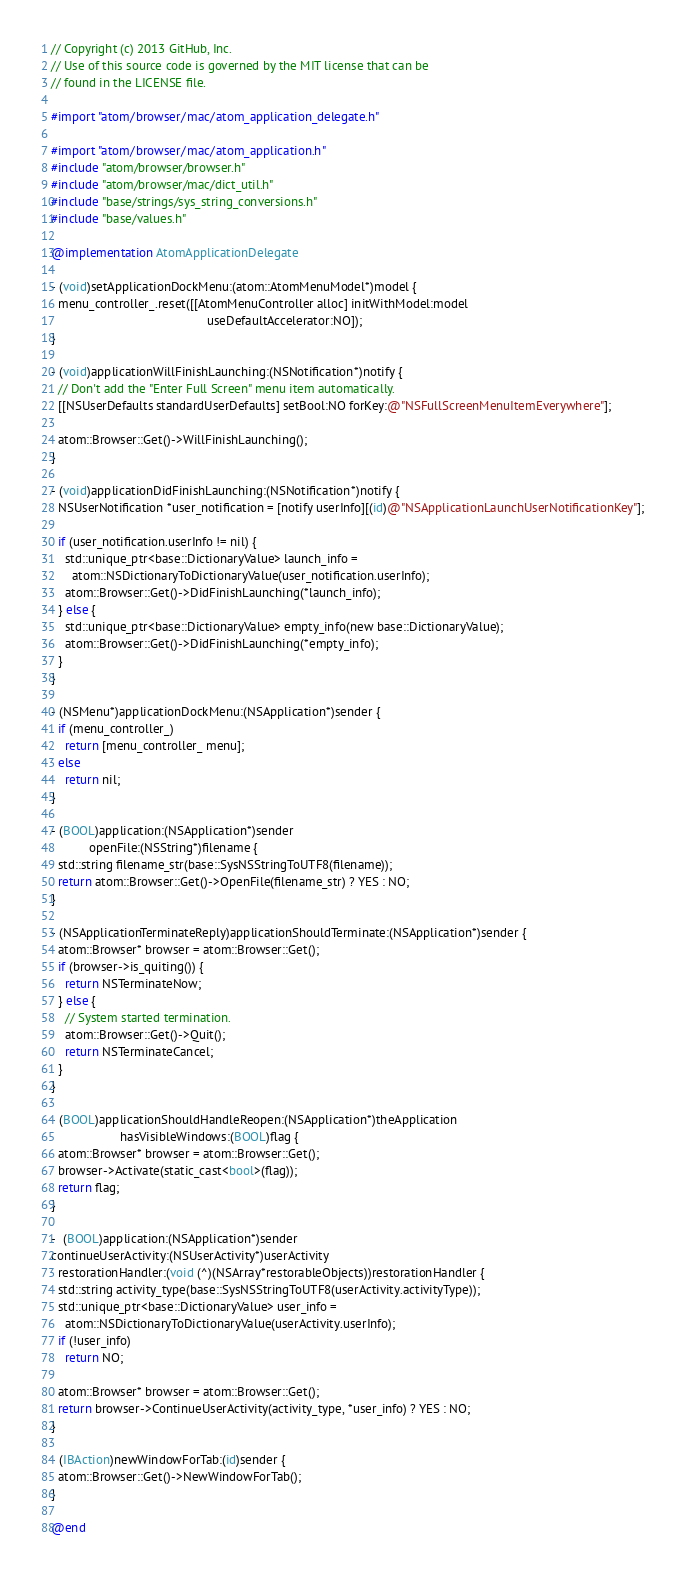<code> <loc_0><loc_0><loc_500><loc_500><_ObjectiveC_>// Copyright (c) 2013 GitHub, Inc.
// Use of this source code is governed by the MIT license that can be
// found in the LICENSE file.

#import "atom/browser/mac/atom_application_delegate.h"

#import "atom/browser/mac/atom_application.h"
#include "atom/browser/browser.h"
#include "atom/browser/mac/dict_util.h"
#include "base/strings/sys_string_conversions.h"
#include "base/values.h"

@implementation AtomApplicationDelegate

- (void)setApplicationDockMenu:(atom::AtomMenuModel*)model {
  menu_controller_.reset([[AtomMenuController alloc] initWithModel:model
                                             useDefaultAccelerator:NO]);
}

- (void)applicationWillFinishLaunching:(NSNotification*)notify {
  // Don't add the "Enter Full Screen" menu item automatically.
  [[NSUserDefaults standardUserDefaults] setBool:NO forKey:@"NSFullScreenMenuItemEverywhere"];

  atom::Browser::Get()->WillFinishLaunching();
}

- (void)applicationDidFinishLaunching:(NSNotification*)notify {
  NSUserNotification *user_notification = [notify userInfo][(id)@"NSApplicationLaunchUserNotificationKey"];

  if (user_notification.userInfo != nil) {
    std::unique_ptr<base::DictionaryValue> launch_info =
      atom::NSDictionaryToDictionaryValue(user_notification.userInfo);
    atom::Browser::Get()->DidFinishLaunching(*launch_info);
  } else {
    std::unique_ptr<base::DictionaryValue> empty_info(new base::DictionaryValue);
    atom::Browser::Get()->DidFinishLaunching(*empty_info);
  }
}

- (NSMenu*)applicationDockMenu:(NSApplication*)sender {
  if (menu_controller_)
    return [menu_controller_ menu];
  else
    return nil;
}

- (BOOL)application:(NSApplication*)sender
           openFile:(NSString*)filename {
  std::string filename_str(base::SysNSStringToUTF8(filename));
  return atom::Browser::Get()->OpenFile(filename_str) ? YES : NO;
}

- (NSApplicationTerminateReply)applicationShouldTerminate:(NSApplication*)sender {
  atom::Browser* browser = atom::Browser::Get();
  if (browser->is_quiting()) {
    return NSTerminateNow;
  } else {
    // System started termination.
    atom::Browser::Get()->Quit();
    return NSTerminateCancel;
  }
}

- (BOOL)applicationShouldHandleReopen:(NSApplication*)theApplication
                    hasVisibleWindows:(BOOL)flag {
  atom::Browser* browser = atom::Browser::Get();
  browser->Activate(static_cast<bool>(flag));
  return flag;
}

-  (BOOL)application:(NSApplication*)sender
continueUserActivity:(NSUserActivity*)userActivity
  restorationHandler:(void (^)(NSArray*restorableObjects))restorationHandler {
  std::string activity_type(base::SysNSStringToUTF8(userActivity.activityType));
  std::unique_ptr<base::DictionaryValue> user_info =
    atom::NSDictionaryToDictionaryValue(userActivity.userInfo);
  if (!user_info)
    return NO;

  atom::Browser* browser = atom::Browser::Get();
  return browser->ContinueUserActivity(activity_type, *user_info) ? YES : NO;
}

- (IBAction)newWindowForTab:(id)sender {
  atom::Browser::Get()->NewWindowForTab();
}

@end
</code> 